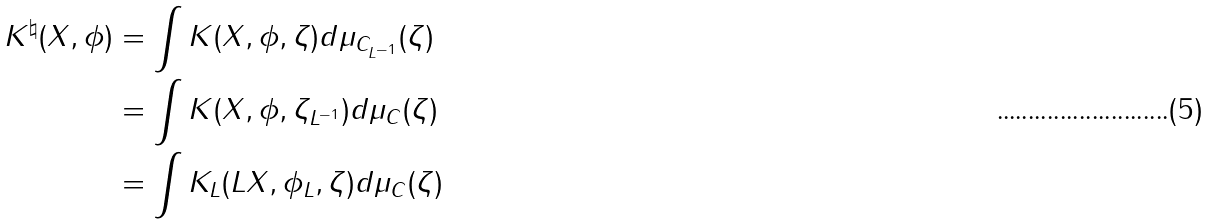Convert formula to latex. <formula><loc_0><loc_0><loc_500><loc_500>K ^ { \natural } ( X , \phi ) & = \int K ( X , \phi , \zeta ) d \mu _ { C _ { L ^ { - 1 } } } ( \zeta ) \\ & = \int K ( X , \phi , \zeta _ { L ^ { - 1 } } ) d \mu _ { C } ( \zeta ) \\ & = \int K _ { L } ( L X , \phi _ { L } , \zeta ) d \mu _ { C } ( \zeta ) \\</formula> 